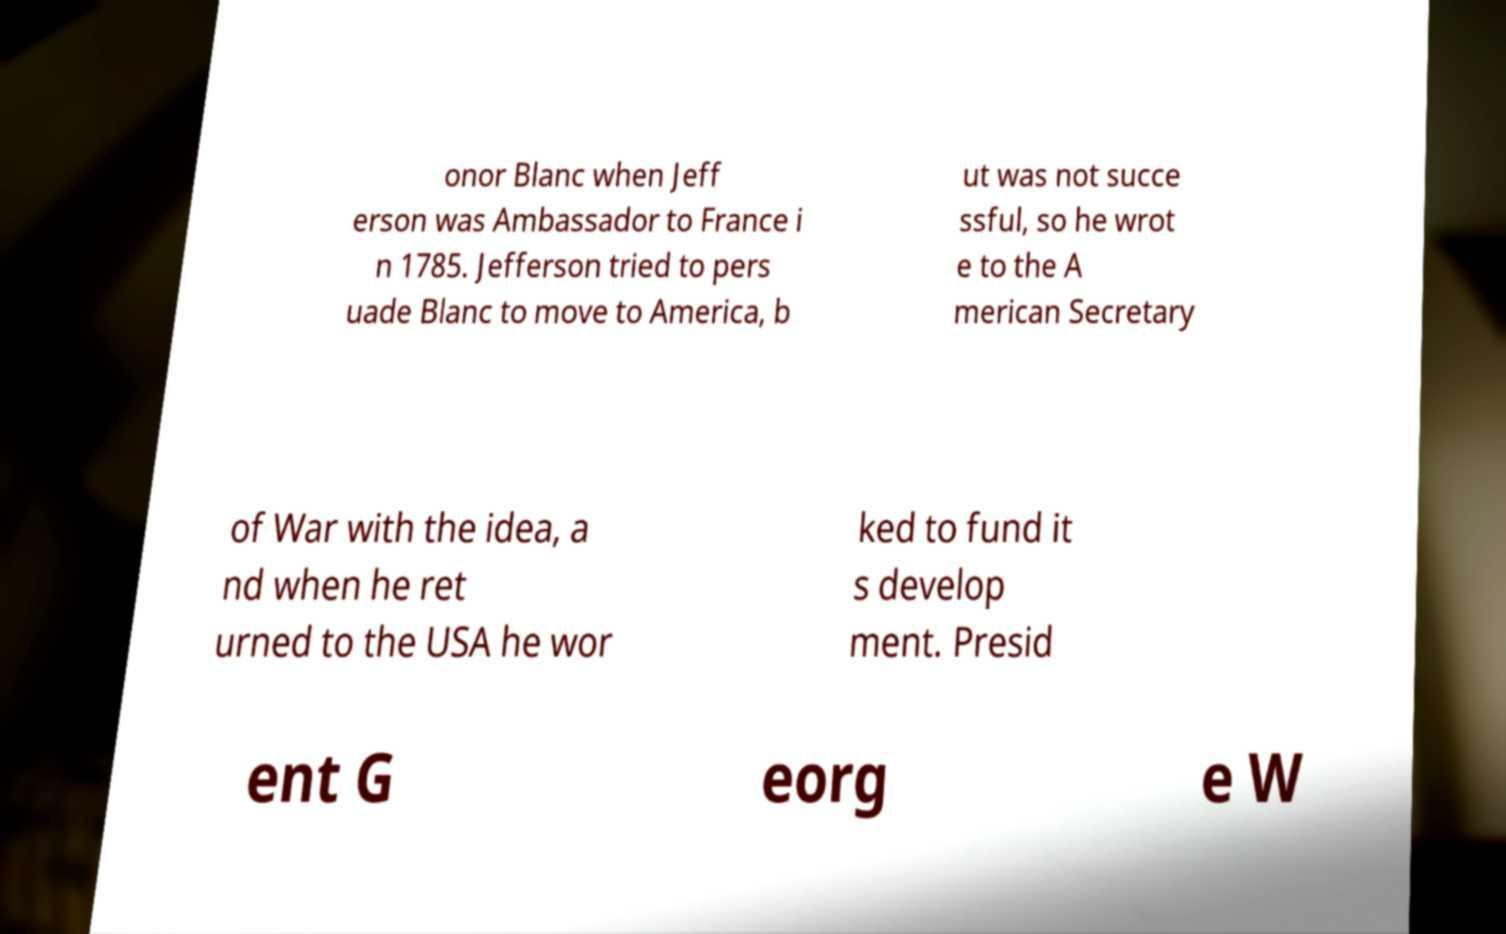There's text embedded in this image that I need extracted. Can you transcribe it verbatim? onor Blanc when Jeff erson was Ambassador to France i n 1785. Jefferson tried to pers uade Blanc to move to America, b ut was not succe ssful, so he wrot e to the A merican Secretary of War with the idea, a nd when he ret urned to the USA he wor ked to fund it s develop ment. Presid ent G eorg e W 